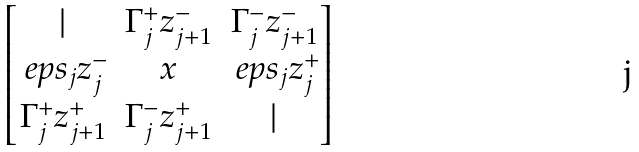<formula> <loc_0><loc_0><loc_500><loc_500>\begin{bmatrix} | & \Gamma ^ { + } _ { j } z ^ { - } _ { j + 1 } & \Gamma ^ { - } _ { j } z ^ { - } _ { j + 1 } \\ \ e p s _ { j } z ^ { - } _ { j } & x & \ e p s _ { j } z ^ { + } _ { j } \\ \Gamma ^ { + } _ { j } z ^ { + } _ { j + 1 } & \Gamma ^ { - } _ { j } z ^ { + } _ { j + 1 } & | \end{bmatrix}</formula> 